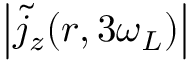Convert formula to latex. <formula><loc_0><loc_0><loc_500><loc_500>\left | \tilde { j } _ { z } ( \boldsymbol r , 3 \omega _ { L } ) \right |</formula> 